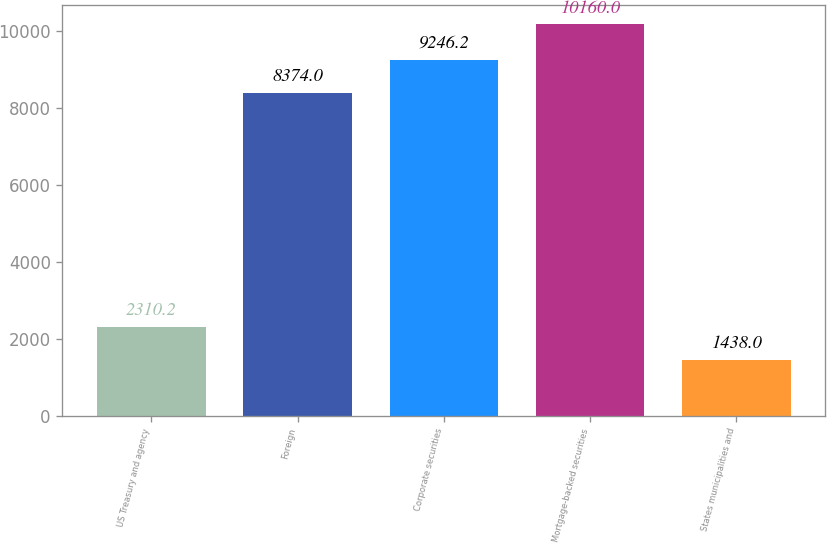Convert chart to OTSL. <chart><loc_0><loc_0><loc_500><loc_500><bar_chart><fcel>US Treasury and agency<fcel>Foreign<fcel>Corporate securities<fcel>Mortgage-backed securities<fcel>States municipalities and<nl><fcel>2310.2<fcel>8374<fcel>9246.2<fcel>10160<fcel>1438<nl></chart> 